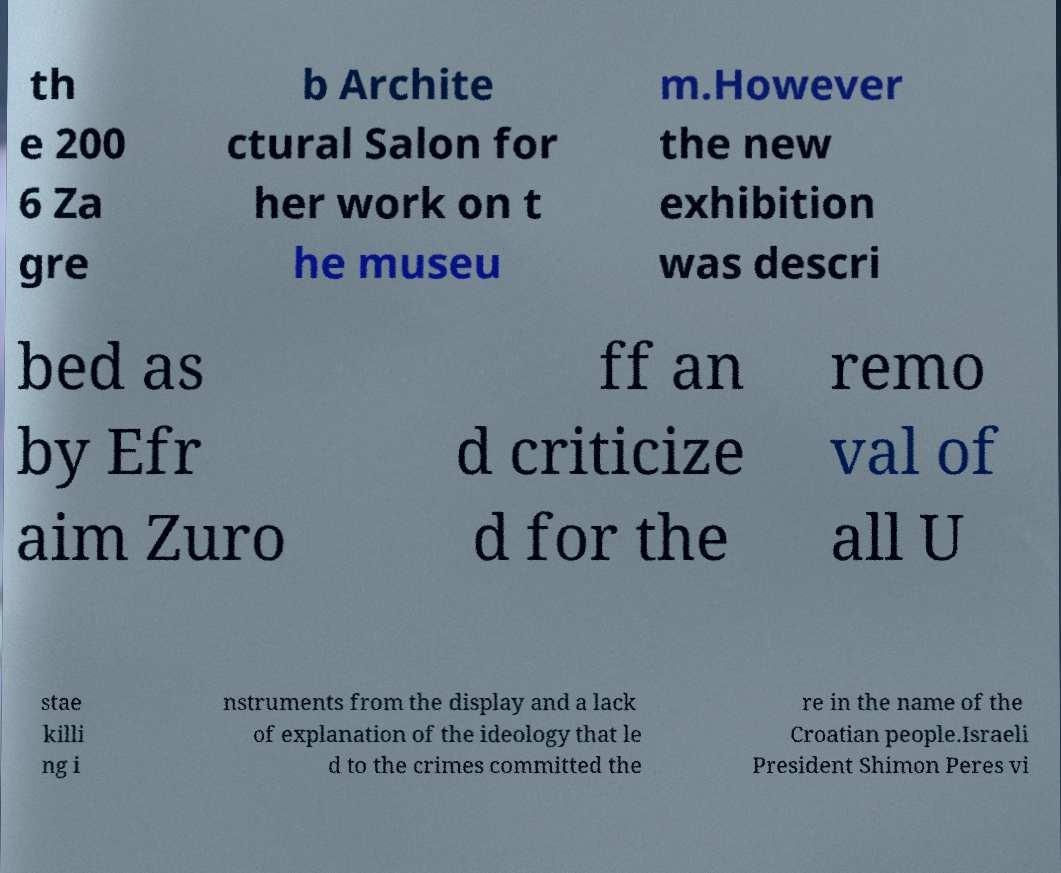Please read and relay the text visible in this image. What does it say? th e 200 6 Za gre b Archite ctural Salon for her work on t he museu m.However the new exhibition was descri bed as by Efr aim Zuro ff an d criticize d for the remo val of all U stae killi ng i nstruments from the display and a lack of explanation of the ideology that le d to the crimes committed the re in the name of the Croatian people.Israeli President Shimon Peres vi 